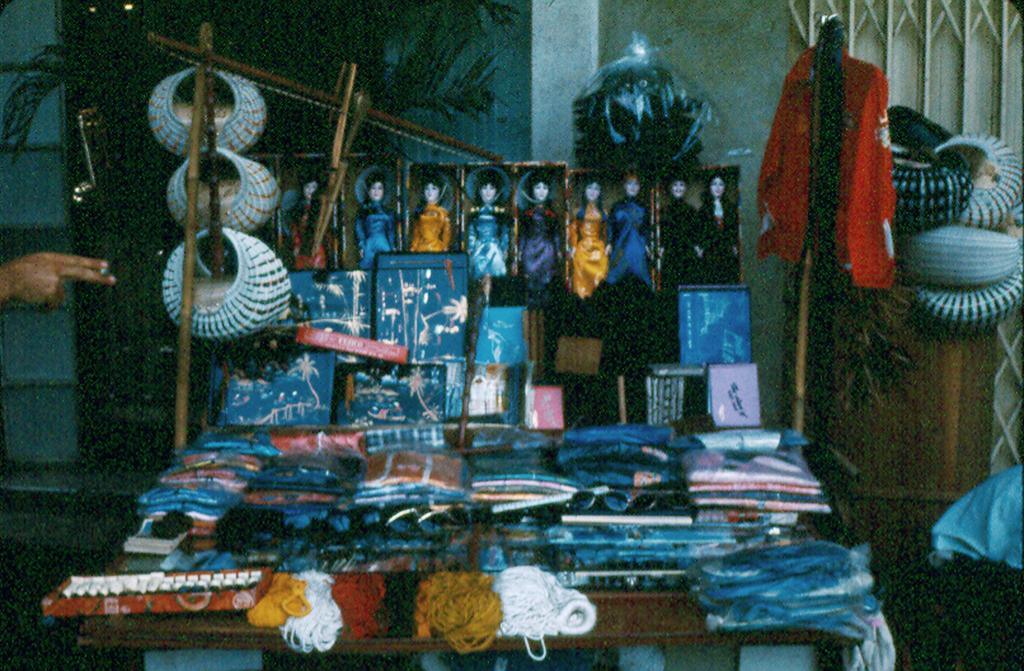What type of items can be seen in the image? There are clothes, dolls, sticks with things on them, and plants in the image. What is the background of the image? There is a wall in the image. Can you describe the objects on the sticks? Unfortunately, the facts provided do not give enough information to describe the objects on the sticks. What type of wood can be seen in the image? There is no wood present in the image. Can you see a zebra in the image? No, there is no zebra in the image. 